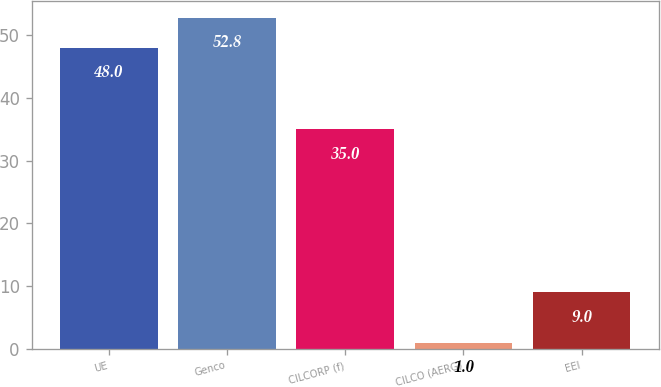<chart> <loc_0><loc_0><loc_500><loc_500><bar_chart><fcel>UE<fcel>Genco<fcel>CILCORP (f)<fcel>CILCO (AERG)<fcel>EEI<nl><fcel>48<fcel>52.8<fcel>35<fcel>1<fcel>9<nl></chart> 